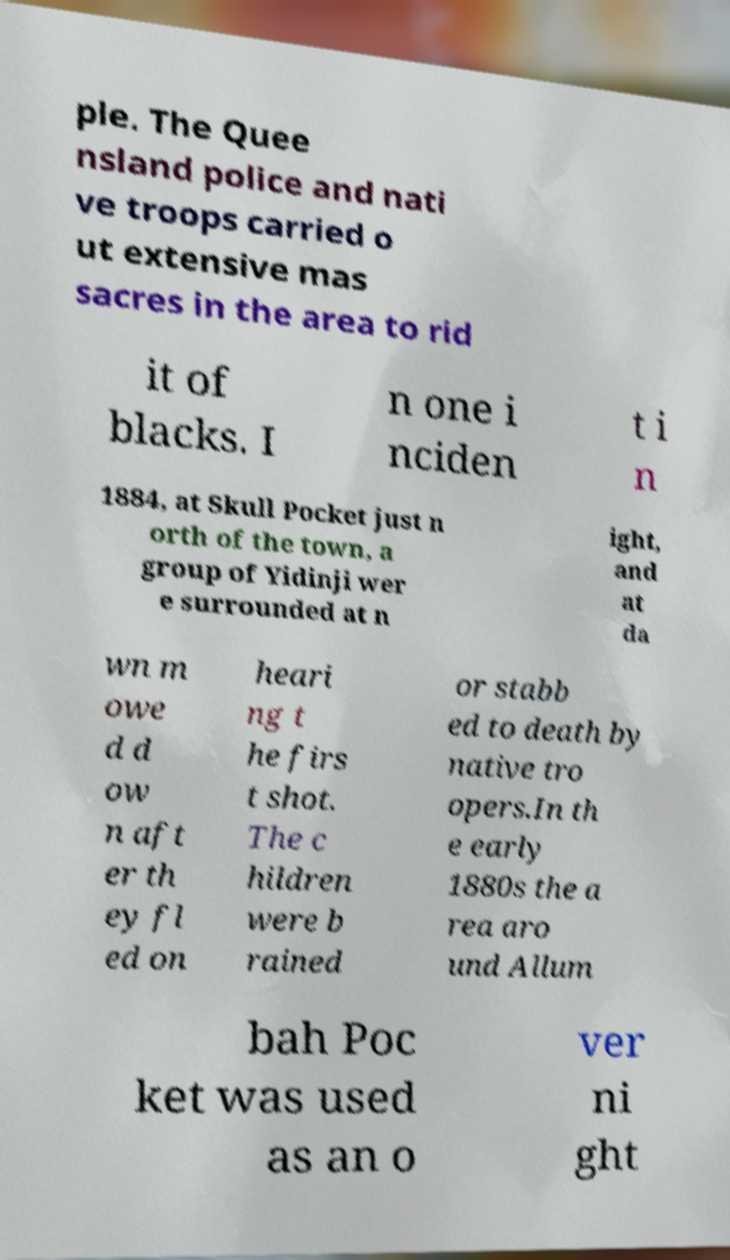There's text embedded in this image that I need extracted. Can you transcribe it verbatim? ple. The Quee nsland police and nati ve troops carried o ut extensive mas sacres in the area to rid it of blacks. I n one i nciden t i n 1884, at Skull Pocket just n orth of the town, a group of Yidinji wer e surrounded at n ight, and at da wn m owe d d ow n aft er th ey fl ed on heari ng t he firs t shot. The c hildren were b rained or stabb ed to death by native tro opers.In th e early 1880s the a rea aro und Allum bah Poc ket was used as an o ver ni ght 